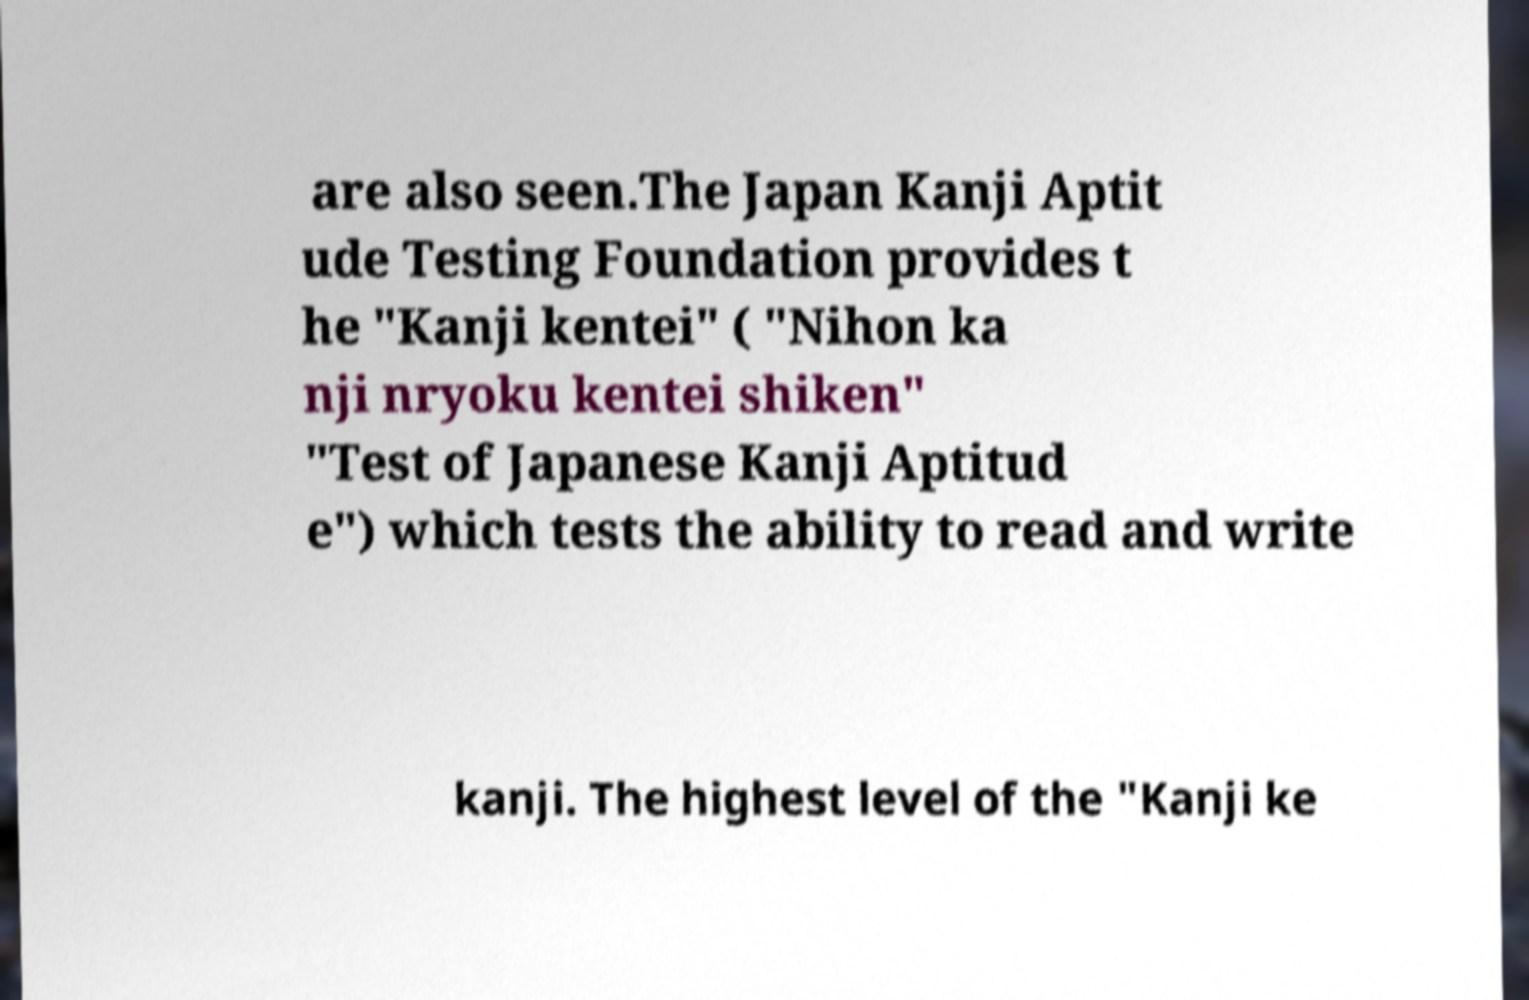What messages or text are displayed in this image? I need them in a readable, typed format. are also seen.The Japan Kanji Aptit ude Testing Foundation provides t he "Kanji kentei" ( "Nihon ka nji nryoku kentei shiken" "Test of Japanese Kanji Aptitud e") which tests the ability to read and write kanji. The highest level of the "Kanji ke 